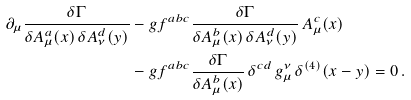<formula> <loc_0><loc_0><loc_500><loc_500>\partial _ { \mu } \frac { \delta \Gamma } { \delta A ^ { a } _ { \mu } ( x ) \, \delta A ^ { d } _ { \nu } ( y ) } & - g f ^ { a b c } \frac { \delta \Gamma } { \delta A ^ { b } _ { \mu } ( x ) \, \delta A ^ { d } _ { \nu } ( y ) } \, A ^ { c } _ { \mu } ( x ) \\ & - g f ^ { a b c } \frac { \delta \Gamma } { \delta A ^ { b } _ { \mu } ( x ) } \, \delta ^ { c d } \, g ^ { \nu } _ { \mu } \, \delta ^ { ( 4 ) } ( x - y ) = 0 \, .</formula> 